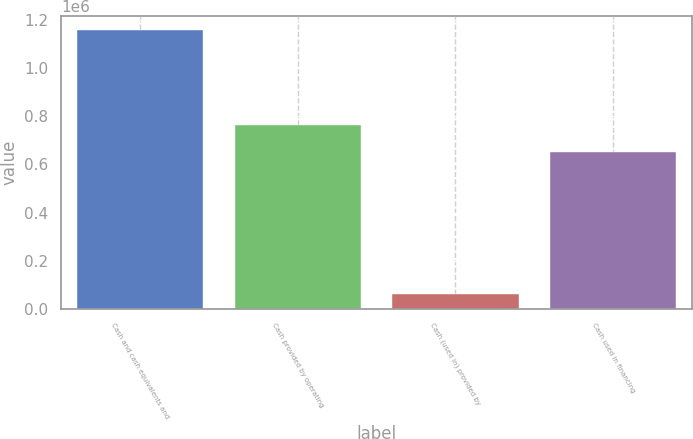<chart> <loc_0><loc_0><loc_500><loc_500><bar_chart><fcel>Cash and cash equivalents and<fcel>Cash provided by operating<fcel>Cash (used in) provided by<fcel>Cash used in financing<nl><fcel>1.15877e+06<fcel>762252<fcel>62720<fcel>652647<nl></chart> 